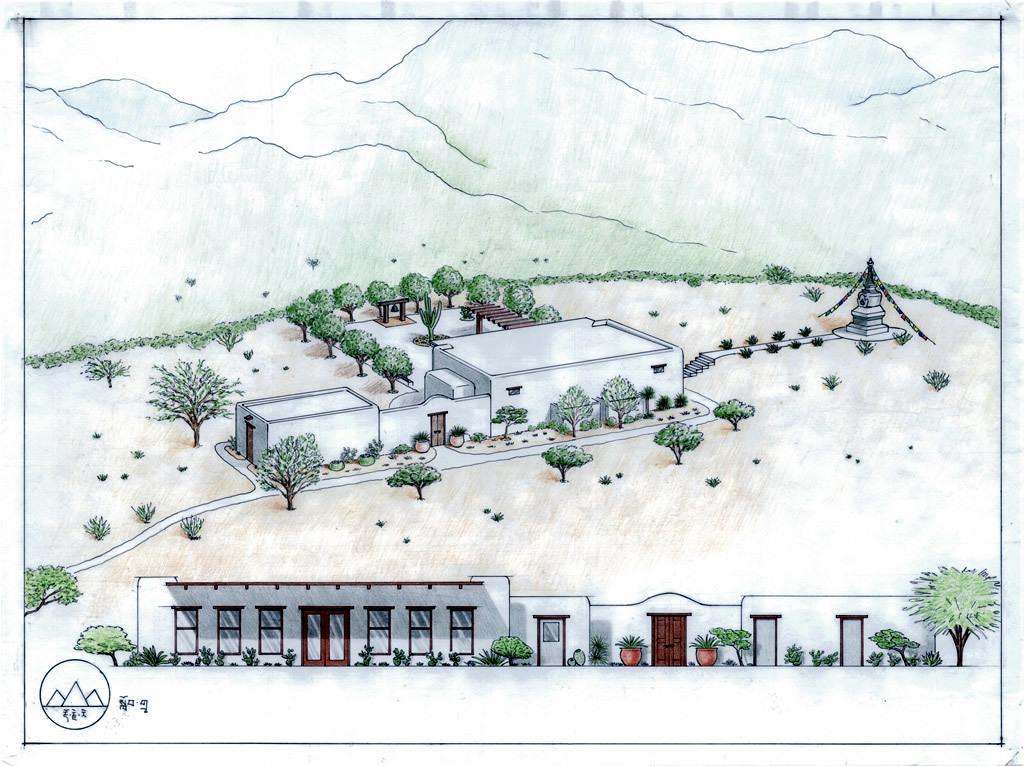Can you describe this image briefly? This is a sketch and here we can see houses, trees, plants, house plants, a tower and we can see mountains. At the bottom, there is a logo and we can see some text. 